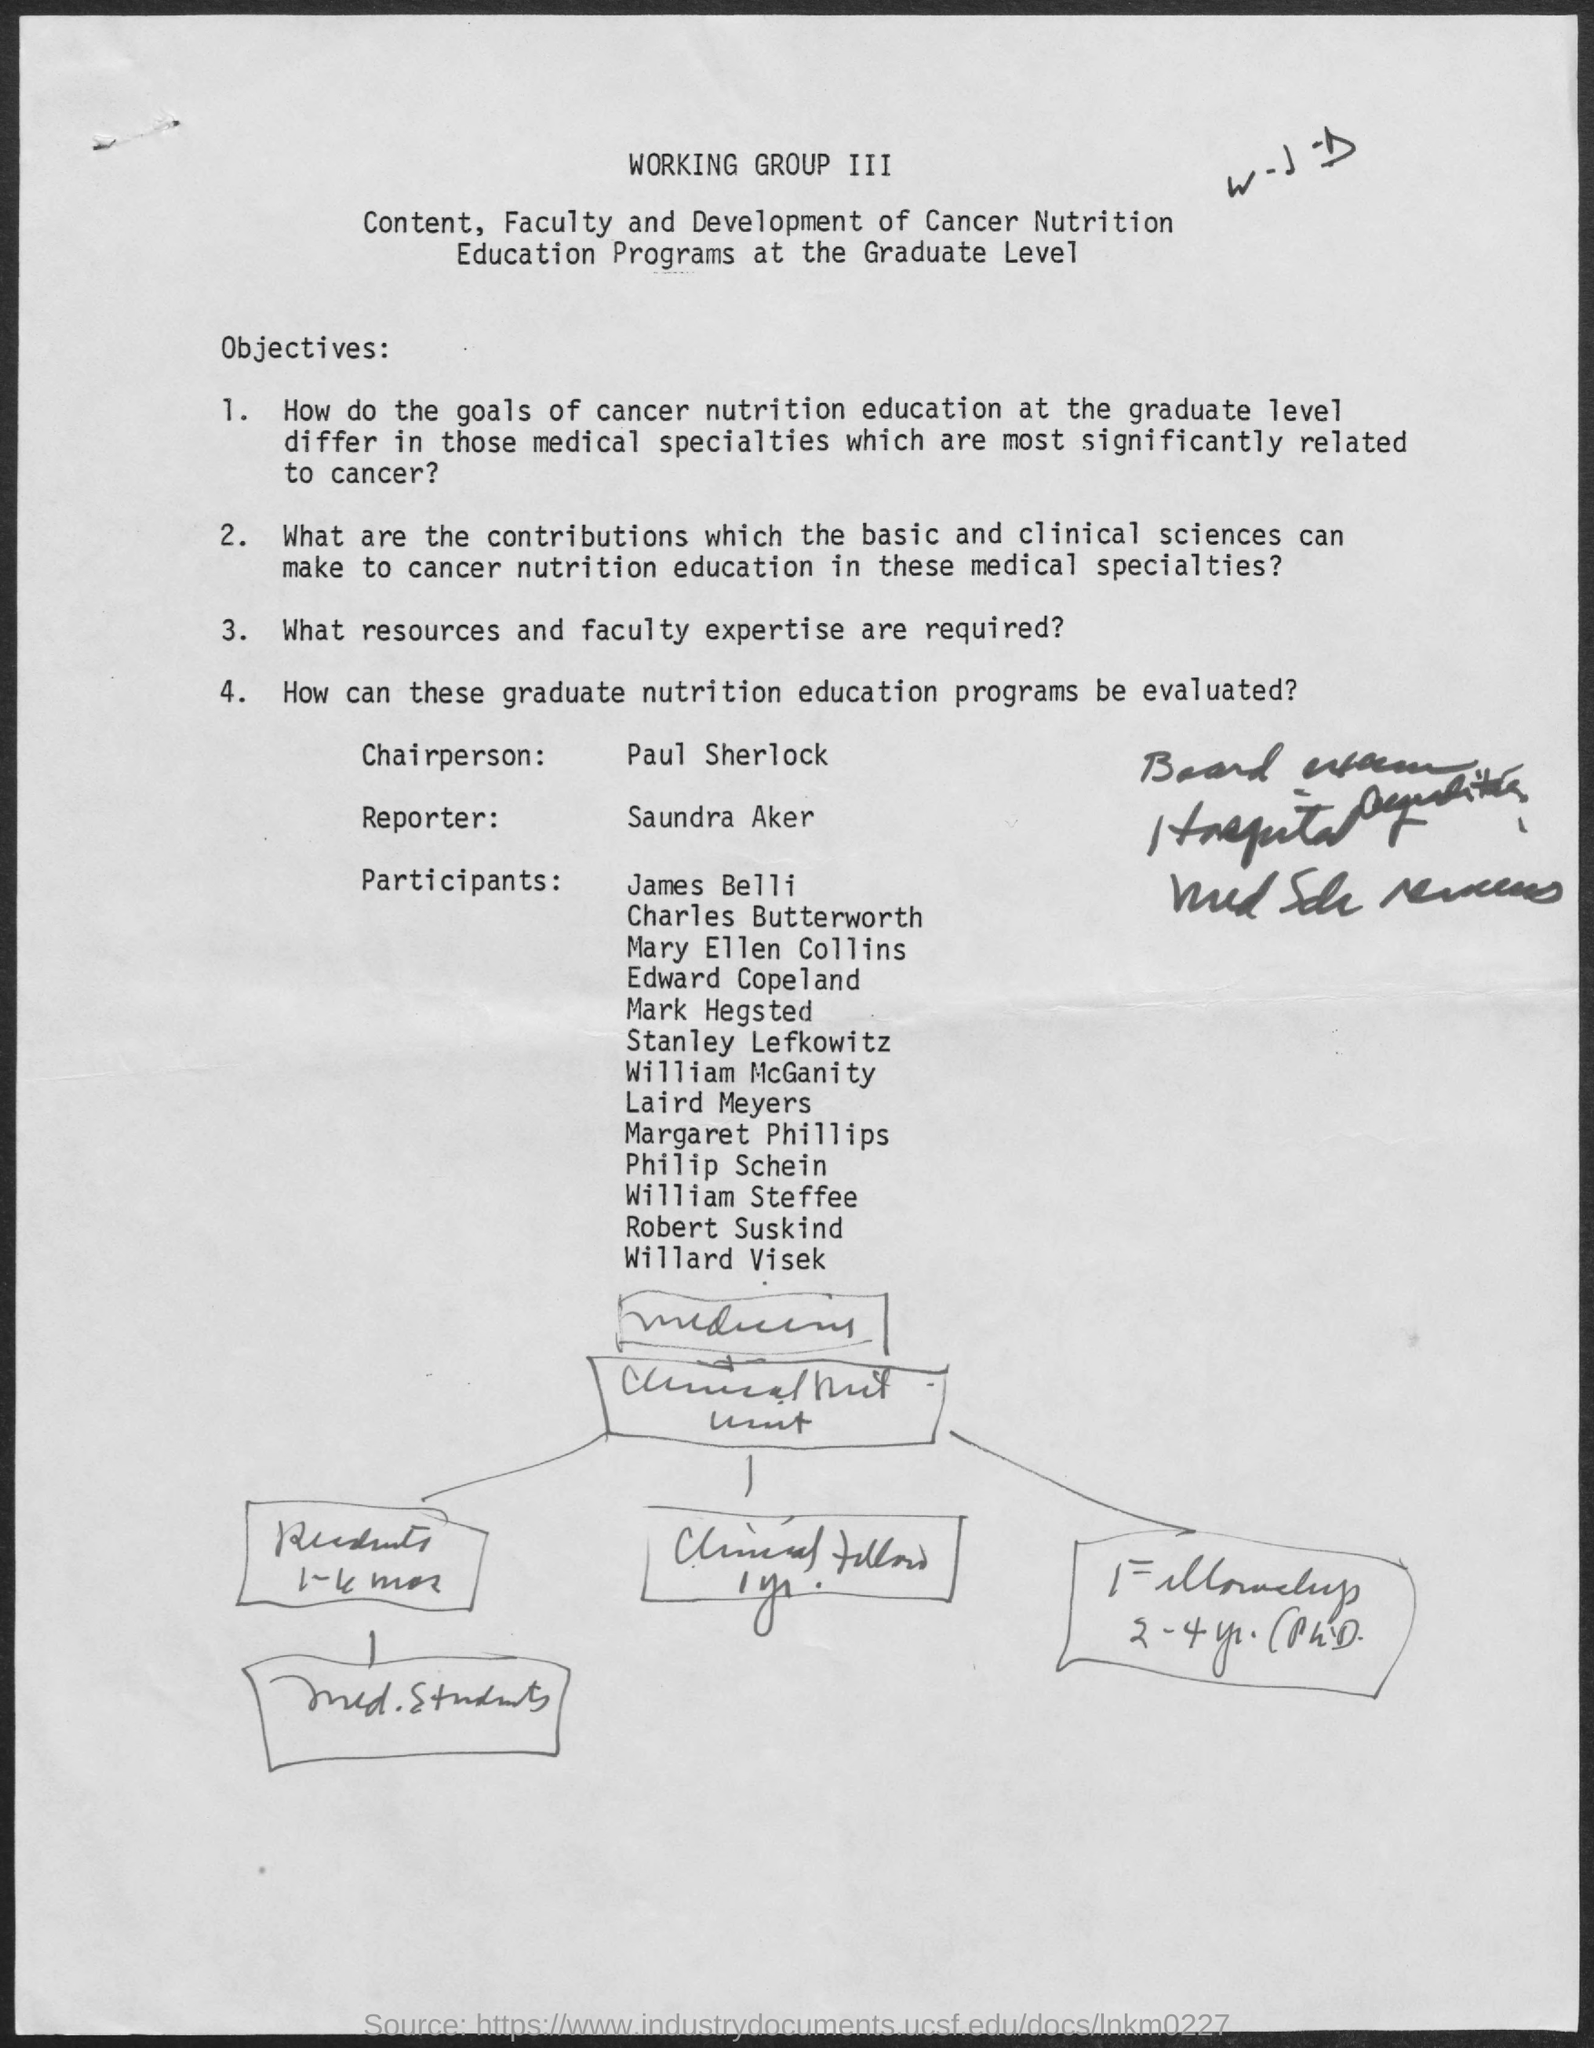Who is the Reporter of this program?
Your response must be concise. SAUNDRA AKER. 